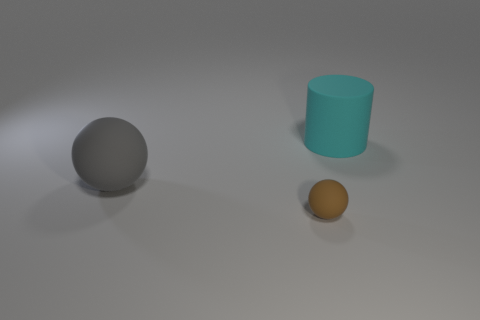Are there any other things that have the same size as the brown matte sphere?
Provide a succinct answer. No. There is a rubber thing that is behind the gray matte ball behind the small matte sphere; are there any large objects that are on the left side of it?
Give a very brief answer. Yes. There is a big gray ball; are there any things behind it?
Your answer should be compact. Yes. What number of things are to the right of the big rubber object in front of the cyan object?
Offer a terse response. 2. There is a cyan matte thing; is its size the same as the thing in front of the gray sphere?
Your answer should be very brief. No. There is a brown ball that is made of the same material as the cyan thing; what is its size?
Provide a short and direct response. Small. What color is the ball that is on the left side of the sphere right of the rubber sphere behind the small brown rubber object?
Give a very brief answer. Gray. The big gray thing has what shape?
Your answer should be very brief. Sphere. Are there the same number of big matte cylinders that are to the left of the large rubber cylinder and red metal cylinders?
Your response must be concise. Yes. What number of cyan matte objects are the same size as the gray matte sphere?
Offer a terse response. 1. 